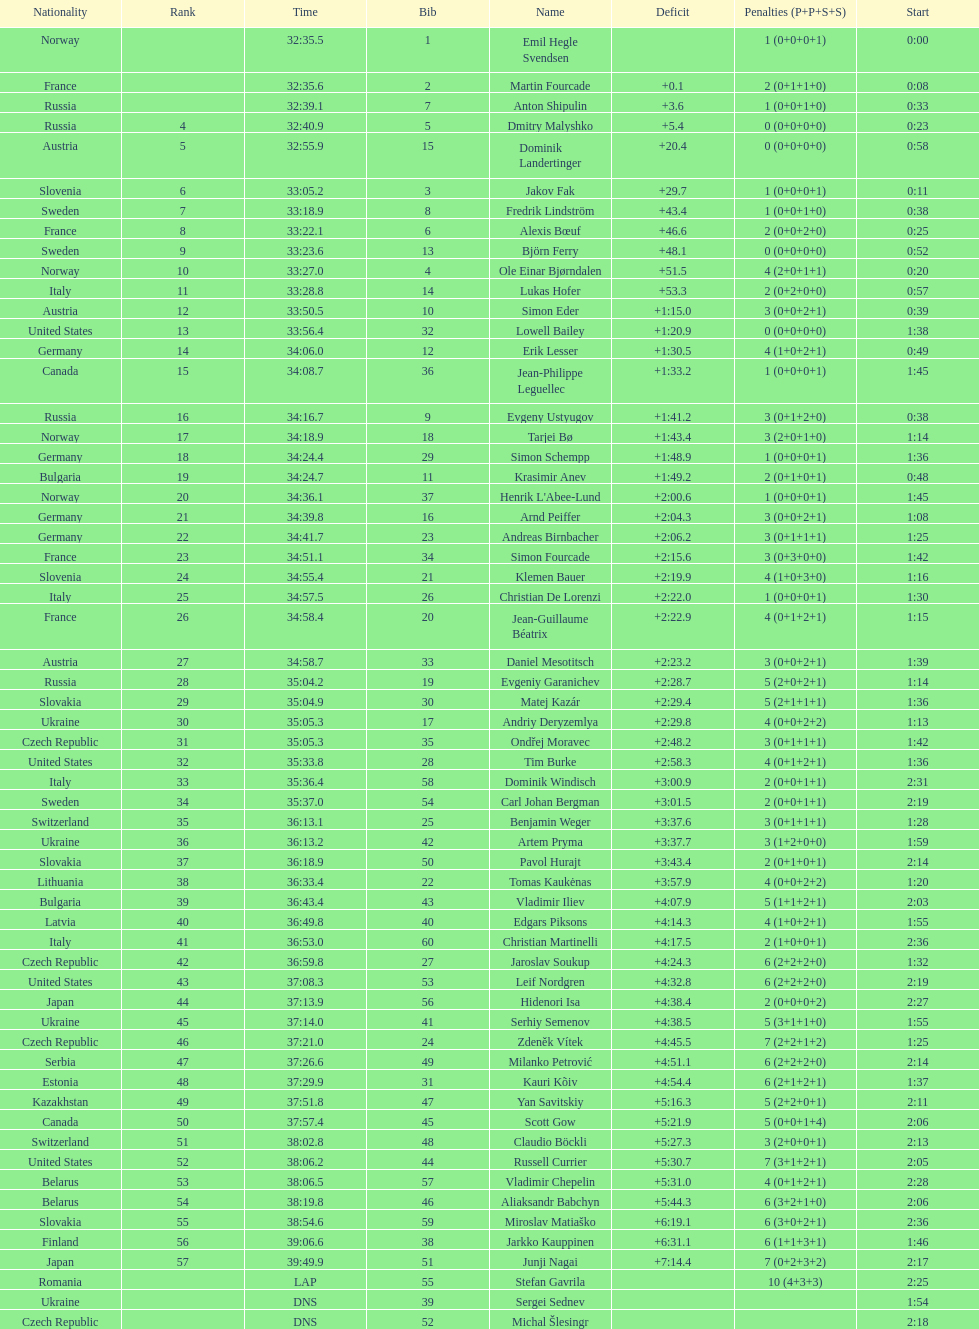What were the total number of "ties" (people who finished with the exact same time?) 2. Parse the table in full. {'header': ['Nationality', 'Rank', 'Time', 'Bib', 'Name', 'Deficit', 'Penalties (P+P+S+S)', 'Start'], 'rows': [['Norway', '', '32:35.5', '1', 'Emil Hegle Svendsen', '', '1 (0+0+0+1)', '0:00'], ['France', '', '32:35.6', '2', 'Martin Fourcade', '+0.1', '2 (0+1+1+0)', '0:08'], ['Russia', '', '32:39.1', '7', 'Anton Shipulin', '+3.6', '1 (0+0+1+0)', '0:33'], ['Russia', '4', '32:40.9', '5', 'Dmitry Malyshko', '+5.4', '0 (0+0+0+0)', '0:23'], ['Austria', '5', '32:55.9', '15', 'Dominik Landertinger', '+20.4', '0 (0+0+0+0)', '0:58'], ['Slovenia', '6', '33:05.2', '3', 'Jakov Fak', '+29.7', '1 (0+0+0+1)', '0:11'], ['Sweden', '7', '33:18.9', '8', 'Fredrik Lindström', '+43.4', '1 (0+0+1+0)', '0:38'], ['France', '8', '33:22.1', '6', 'Alexis Bœuf', '+46.6', '2 (0+0+2+0)', '0:25'], ['Sweden', '9', '33:23.6', '13', 'Björn Ferry', '+48.1', '0 (0+0+0+0)', '0:52'], ['Norway', '10', '33:27.0', '4', 'Ole Einar Bjørndalen', '+51.5', '4 (2+0+1+1)', '0:20'], ['Italy', '11', '33:28.8', '14', 'Lukas Hofer', '+53.3', '2 (0+2+0+0)', '0:57'], ['Austria', '12', '33:50.5', '10', 'Simon Eder', '+1:15.0', '3 (0+0+2+1)', '0:39'], ['United States', '13', '33:56.4', '32', 'Lowell Bailey', '+1:20.9', '0 (0+0+0+0)', '1:38'], ['Germany', '14', '34:06.0', '12', 'Erik Lesser', '+1:30.5', '4 (1+0+2+1)', '0:49'], ['Canada', '15', '34:08.7', '36', 'Jean-Philippe Leguellec', '+1:33.2', '1 (0+0+0+1)', '1:45'], ['Russia', '16', '34:16.7', '9', 'Evgeny Ustyugov', '+1:41.2', '3 (0+1+2+0)', '0:38'], ['Norway', '17', '34:18.9', '18', 'Tarjei Bø', '+1:43.4', '3 (2+0+1+0)', '1:14'], ['Germany', '18', '34:24.4', '29', 'Simon Schempp', '+1:48.9', '1 (0+0+0+1)', '1:36'], ['Bulgaria', '19', '34:24.7', '11', 'Krasimir Anev', '+1:49.2', '2 (0+1+0+1)', '0:48'], ['Norway', '20', '34:36.1', '37', "Henrik L'Abee-Lund", '+2:00.6', '1 (0+0+0+1)', '1:45'], ['Germany', '21', '34:39.8', '16', 'Arnd Peiffer', '+2:04.3', '3 (0+0+2+1)', '1:08'], ['Germany', '22', '34:41.7', '23', 'Andreas Birnbacher', '+2:06.2', '3 (0+1+1+1)', '1:25'], ['France', '23', '34:51.1', '34', 'Simon Fourcade', '+2:15.6', '3 (0+3+0+0)', '1:42'], ['Slovenia', '24', '34:55.4', '21', 'Klemen Bauer', '+2:19.9', '4 (1+0+3+0)', '1:16'], ['Italy', '25', '34:57.5', '26', 'Christian De Lorenzi', '+2:22.0', '1 (0+0+0+1)', '1:30'], ['France', '26', '34:58.4', '20', 'Jean-Guillaume Béatrix', '+2:22.9', '4 (0+1+2+1)', '1:15'], ['Austria', '27', '34:58.7', '33', 'Daniel Mesotitsch', '+2:23.2', '3 (0+0+2+1)', '1:39'], ['Russia', '28', '35:04.2', '19', 'Evgeniy Garanichev', '+2:28.7', '5 (2+0+2+1)', '1:14'], ['Slovakia', '29', '35:04.9', '30', 'Matej Kazár', '+2:29.4', '5 (2+1+1+1)', '1:36'], ['Ukraine', '30', '35:05.3', '17', 'Andriy Deryzemlya', '+2:29.8', '4 (0+0+2+2)', '1:13'], ['Czech Republic', '31', '35:05.3', '35', 'Ondřej Moravec', '+2:48.2', '3 (0+1+1+1)', '1:42'], ['United States', '32', '35:33.8', '28', 'Tim Burke', '+2:58.3', '4 (0+1+2+1)', '1:36'], ['Italy', '33', '35:36.4', '58', 'Dominik Windisch', '+3:00.9', '2 (0+0+1+1)', '2:31'], ['Sweden', '34', '35:37.0', '54', 'Carl Johan Bergman', '+3:01.5', '2 (0+0+1+1)', '2:19'], ['Switzerland', '35', '36:13.1', '25', 'Benjamin Weger', '+3:37.6', '3 (0+1+1+1)', '1:28'], ['Ukraine', '36', '36:13.2', '42', 'Artem Pryma', '+3:37.7', '3 (1+2+0+0)', '1:59'], ['Slovakia', '37', '36:18.9', '50', 'Pavol Hurajt', '+3:43.4', '2 (0+1+0+1)', '2:14'], ['Lithuania', '38', '36:33.4', '22', 'Tomas Kaukėnas', '+3:57.9', '4 (0+0+2+2)', '1:20'], ['Bulgaria', '39', '36:43.4', '43', 'Vladimir Iliev', '+4:07.9', '5 (1+1+2+1)', '2:03'], ['Latvia', '40', '36:49.8', '40', 'Edgars Piksons', '+4:14.3', '4 (1+0+2+1)', '1:55'], ['Italy', '41', '36:53.0', '60', 'Christian Martinelli', '+4:17.5', '2 (1+0+0+1)', '2:36'], ['Czech Republic', '42', '36:59.8', '27', 'Jaroslav Soukup', '+4:24.3', '6 (2+2+2+0)', '1:32'], ['United States', '43', '37:08.3', '53', 'Leif Nordgren', '+4:32.8', '6 (2+2+2+0)', '2:19'], ['Japan', '44', '37:13.9', '56', 'Hidenori Isa', '+4:38.4', '2 (0+0+0+2)', '2:27'], ['Ukraine', '45', '37:14.0', '41', 'Serhiy Semenov', '+4:38.5', '5 (3+1+1+0)', '1:55'], ['Czech Republic', '46', '37:21.0', '24', 'Zdeněk Vítek', '+4:45.5', '7 (2+2+1+2)', '1:25'], ['Serbia', '47', '37:26.6', '49', 'Milanko Petrović', '+4:51.1', '6 (2+2+2+0)', '2:14'], ['Estonia', '48', '37:29.9', '31', 'Kauri Kõiv', '+4:54.4', '6 (2+1+2+1)', '1:37'], ['Kazakhstan', '49', '37:51.8', '47', 'Yan Savitskiy', '+5:16.3', '5 (2+2+0+1)', '2:11'], ['Canada', '50', '37:57.4', '45', 'Scott Gow', '+5:21.9', '5 (0+0+1+4)', '2:06'], ['Switzerland', '51', '38:02.8', '48', 'Claudio Böckli', '+5:27.3', '3 (2+0+0+1)', '2:13'], ['United States', '52', '38:06.2', '44', 'Russell Currier', '+5:30.7', '7 (3+1+2+1)', '2:05'], ['Belarus', '53', '38:06.5', '57', 'Vladimir Chepelin', '+5:31.0', '4 (0+1+2+1)', '2:28'], ['Belarus', '54', '38:19.8', '46', 'Aliaksandr Babchyn', '+5:44.3', '6 (3+2+1+0)', '2:06'], ['Slovakia', '55', '38:54.6', '59', 'Miroslav Matiaško', '+6:19.1', '6 (3+0+2+1)', '2:36'], ['Finland', '56', '39:06.6', '38', 'Jarkko Kauppinen', '+6:31.1', '6 (1+1+3+1)', '1:46'], ['Japan', '57', '39:49.9', '51', 'Junji Nagai', '+7:14.4', '7 (0+2+3+2)', '2:17'], ['Romania', '', 'LAP', '55', 'Stefan Gavrila', '', '10 (4+3+3)', '2:25'], ['Ukraine', '', 'DNS', '39', 'Sergei Sednev', '', '', '1:54'], ['Czech Republic', '', 'DNS', '52', 'Michal Šlesingr', '', '', '2:18']]} 